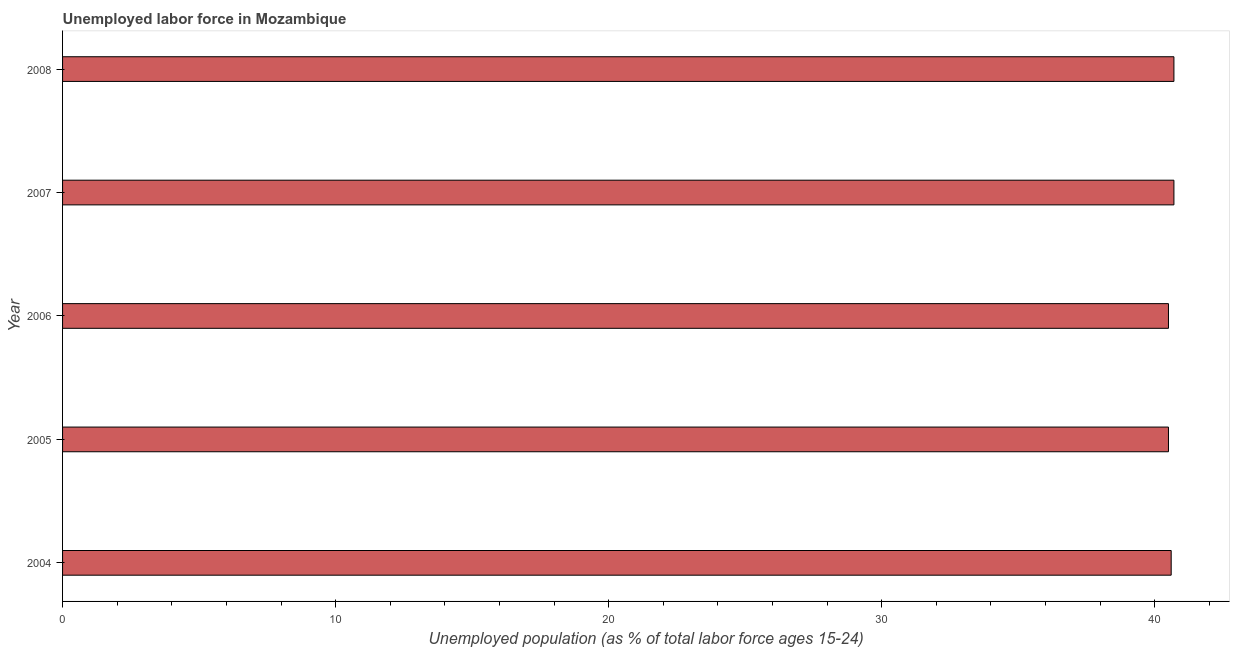Does the graph contain any zero values?
Your response must be concise. No. What is the title of the graph?
Offer a very short reply. Unemployed labor force in Mozambique. What is the label or title of the X-axis?
Provide a succinct answer. Unemployed population (as % of total labor force ages 15-24). What is the label or title of the Y-axis?
Offer a terse response. Year. What is the total unemployed youth population in 2005?
Your answer should be very brief. 40.5. Across all years, what is the maximum total unemployed youth population?
Your answer should be very brief. 40.7. Across all years, what is the minimum total unemployed youth population?
Provide a short and direct response. 40.5. In which year was the total unemployed youth population minimum?
Ensure brevity in your answer.  2005. What is the sum of the total unemployed youth population?
Offer a very short reply. 203. What is the difference between the total unemployed youth population in 2004 and 2008?
Offer a terse response. -0.1. What is the average total unemployed youth population per year?
Ensure brevity in your answer.  40.6. What is the median total unemployed youth population?
Give a very brief answer. 40.6. In how many years, is the total unemployed youth population greater than 38 %?
Ensure brevity in your answer.  5. Is the total unemployed youth population in 2005 less than that in 2008?
Provide a short and direct response. Yes. Is the sum of the total unemployed youth population in 2006 and 2007 greater than the maximum total unemployed youth population across all years?
Offer a terse response. Yes. In how many years, is the total unemployed youth population greater than the average total unemployed youth population taken over all years?
Your answer should be very brief. 2. How many bars are there?
Provide a short and direct response. 5. Are all the bars in the graph horizontal?
Ensure brevity in your answer.  Yes. What is the Unemployed population (as % of total labor force ages 15-24) in 2004?
Give a very brief answer. 40.6. What is the Unemployed population (as % of total labor force ages 15-24) of 2005?
Your answer should be compact. 40.5. What is the Unemployed population (as % of total labor force ages 15-24) in 2006?
Make the answer very short. 40.5. What is the Unemployed population (as % of total labor force ages 15-24) in 2007?
Keep it short and to the point. 40.7. What is the Unemployed population (as % of total labor force ages 15-24) in 2008?
Your answer should be very brief. 40.7. What is the difference between the Unemployed population (as % of total labor force ages 15-24) in 2004 and 2005?
Provide a succinct answer. 0.1. What is the difference between the Unemployed population (as % of total labor force ages 15-24) in 2004 and 2006?
Offer a very short reply. 0.1. What is the difference between the Unemployed population (as % of total labor force ages 15-24) in 2004 and 2008?
Offer a very short reply. -0.1. What is the difference between the Unemployed population (as % of total labor force ages 15-24) in 2005 and 2007?
Provide a succinct answer. -0.2. What is the difference between the Unemployed population (as % of total labor force ages 15-24) in 2005 and 2008?
Ensure brevity in your answer.  -0.2. What is the difference between the Unemployed population (as % of total labor force ages 15-24) in 2006 and 2007?
Your response must be concise. -0.2. What is the difference between the Unemployed population (as % of total labor force ages 15-24) in 2006 and 2008?
Offer a very short reply. -0.2. What is the ratio of the Unemployed population (as % of total labor force ages 15-24) in 2004 to that in 2005?
Offer a very short reply. 1. What is the ratio of the Unemployed population (as % of total labor force ages 15-24) in 2004 to that in 2008?
Your answer should be very brief. 1. What is the ratio of the Unemployed population (as % of total labor force ages 15-24) in 2005 to that in 2006?
Your answer should be very brief. 1. What is the ratio of the Unemployed population (as % of total labor force ages 15-24) in 2005 to that in 2008?
Your answer should be very brief. 0.99. What is the ratio of the Unemployed population (as % of total labor force ages 15-24) in 2006 to that in 2008?
Offer a terse response. 0.99. What is the ratio of the Unemployed population (as % of total labor force ages 15-24) in 2007 to that in 2008?
Make the answer very short. 1. 